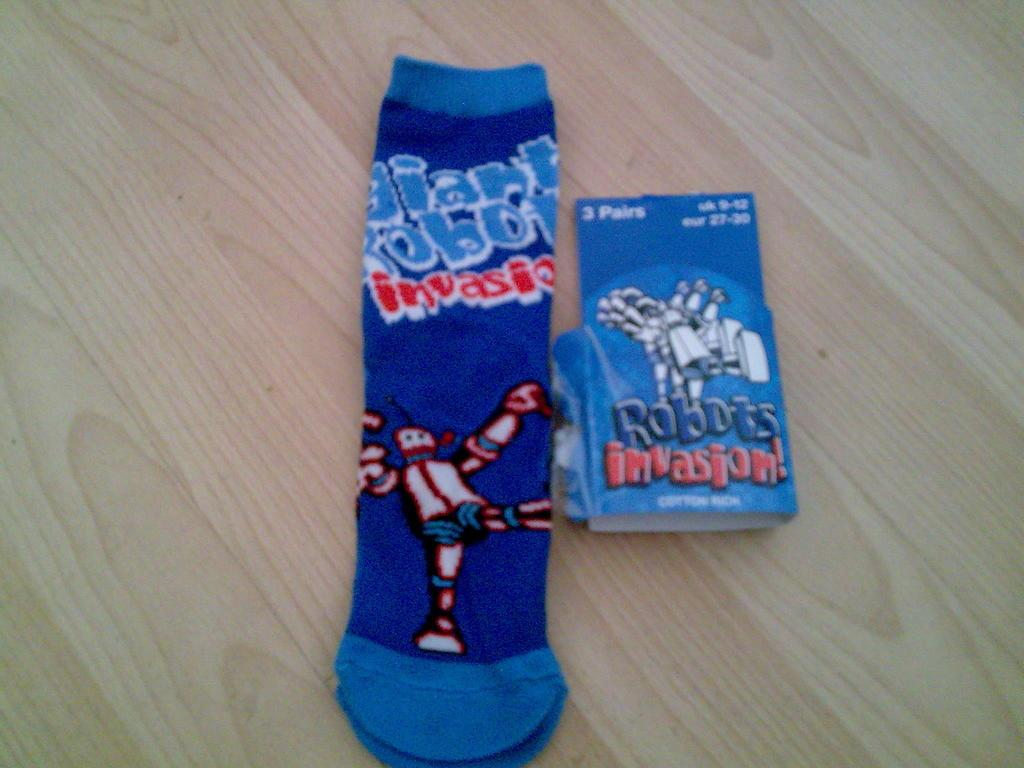What is the design on the sock in the image? There is a sock with a robot printed on it in the image. What other item is present in the image? There is a card in the image. How are the sock and the card related in the image? The sock is removed from the card in the image. Where are the sock and the card placed in the image? Both the sock and the card are placed on a table in the image. What type of flower is growing in the tub in the image? There is no tub or flower present in the image. 